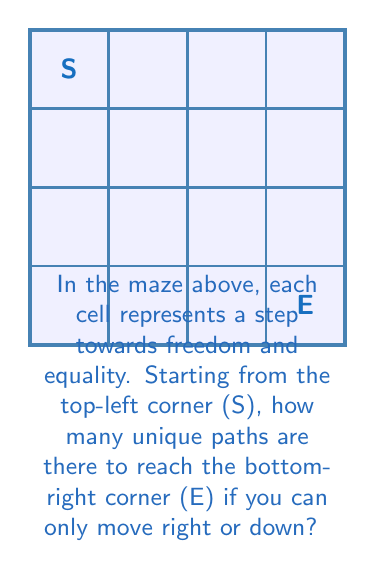Teach me how to tackle this problem. Let's approach this step-by-step:

1) First, we need to understand that to reach the end (E) from the start (S), we must move 3 steps right and 3 steps down in any order.

2) This problem can be solved using combinations. We need to choose the positions for either the right moves or the down moves out of the total 6 moves.

3) We can calculate this using the combination formula:

   $$\binom{6}{3} = \frac{6!}{3!(6-3)!} = \frac{6!}{3!3!}$$

4) Let's calculate this:
   $$\frac{6 * 5 * 4 * 3!}{(3 * 2 * 1)(3 * 2 * 1)} = \frac{120}{6} = 20$$

5) Another way to think about this is to use Pascal's triangle. The number of paths to any cell is the sum of paths to the cell above it and to its left. If we fill in the maze, we get:

   [asy]
   unitsize(1cm);
   for(int i=0; i<4; ++i) {
     for(int j=0; j<4; ++j) {
       draw((i,j)--(i+1,j)--(i+1,j+1)--(i,j+1)--cycle);
     }
   }
   label("1", (0.5,3.5));
   label("1", (1.5,3.5));
   label("1", (2.5,3.5));
   label("1", (3.5,3.5));
   label("1", (0.5,2.5));
   label("2", (1.5,2.5));
   label("3", (2.5,2.5));
   label("4", (3.5,2.5));
   label("1", (0.5,1.5));
   label("3", (1.5,1.5));
   label("6", (2.5,1.5));
   label("10", (3.5,1.5));
   label("1", (0.5,0.5));
   label("4", (1.5,0.5));
   label("10", (2.5,0.5));
   label("20", (3.5,0.5));
   [/asy]

6) The bottom-right cell shows 20, which is our answer.

This maze problem symbolizes the multiple paths one might take in the journey towards freedom and equality, reflecting the experiences of those from countries with human rights challenges.
Answer: 20 